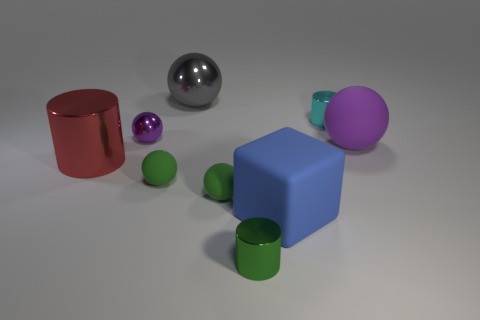Can you describe the different shapes and colors present in this image? Certainly! The image contains a variety of geometric shapes in different colors. There's a large red cylinder with a reflective surface, a blue cube, a magenta sphere, and several smaller objects, including green spheres and a small cyan cylinder. There's also a metallic sphere in the center that displays a mirror-like finish reflecting the environment. How would you describe the lighting and mood of the scene? The lighting in the scene appears to be soft and diffused, with shadows gently cast beneath the objects, indicating an overhead light source. This indirect lighting creates a calm and neutral mood, focusing attention on the colors and shapes of the objects rather than the atmosphere. 